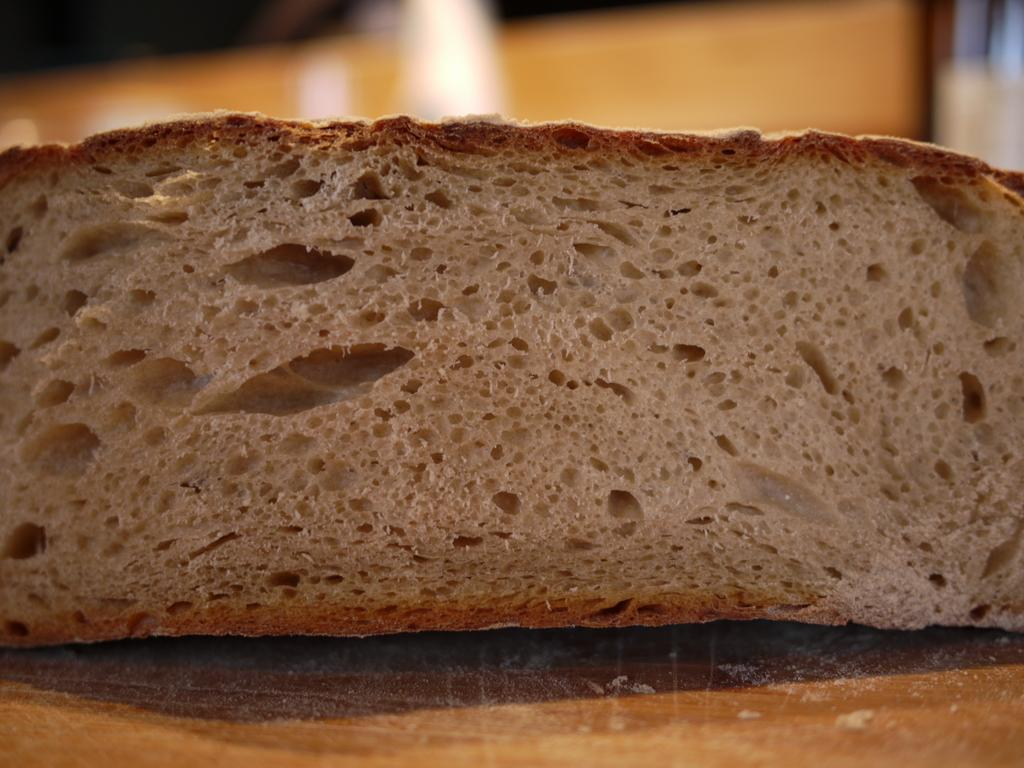What is the main subject of the image? The main subject of the image is a bread piece on a platform. Can you describe the platform the bread is on? Unfortunately, the image is blurred, so it is difficult to provide a detailed description of the platform. Are there any other objects visible in the image? Yes, there are objects visible in the background of the image, although the image is blurred. What type of advice can be heard from the bread in the image? There is no indication in the image that the bread is providing any advice, as it is an inanimate object. 